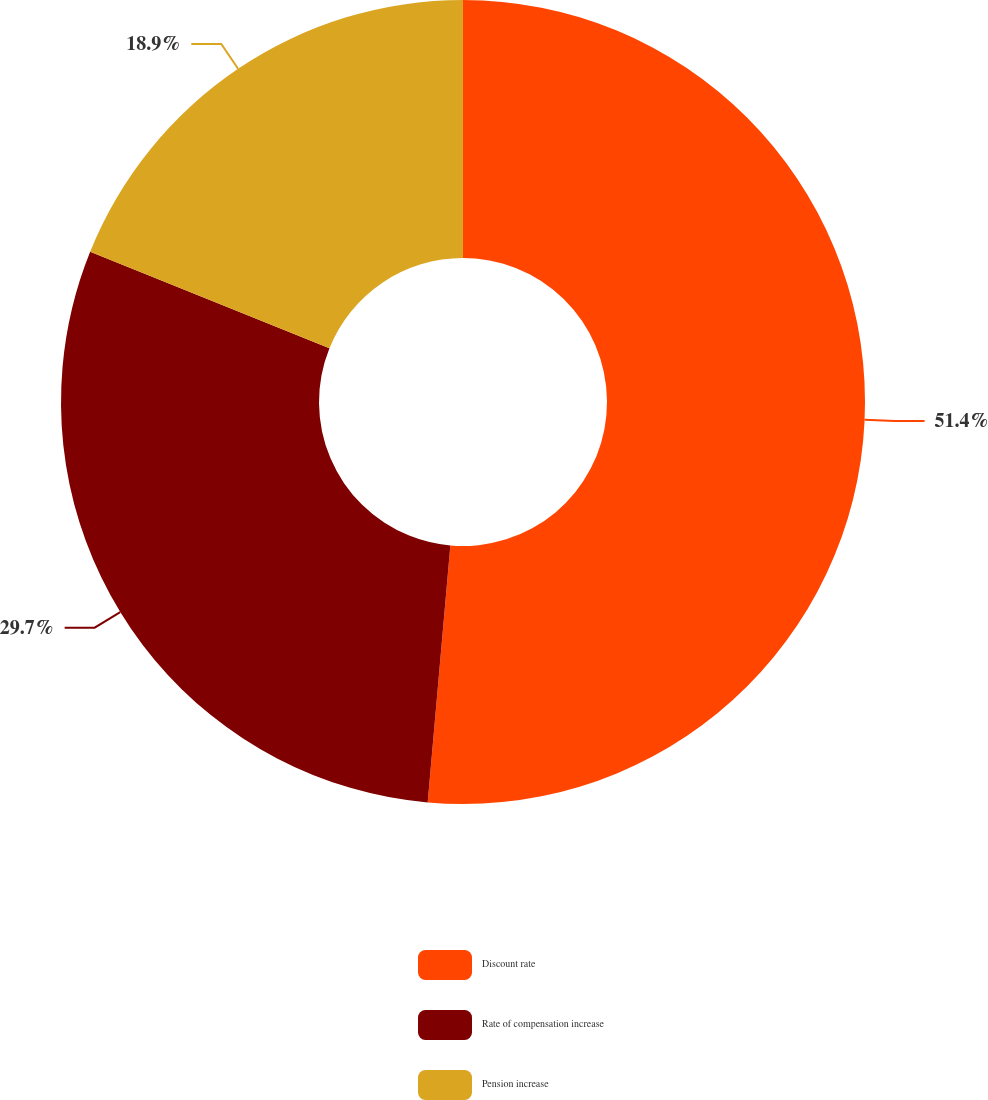Convert chart to OTSL. <chart><loc_0><loc_0><loc_500><loc_500><pie_chart><fcel>Discount rate<fcel>Rate of compensation increase<fcel>Pension increase<nl><fcel>51.4%<fcel>29.7%<fcel>18.9%<nl></chart> 